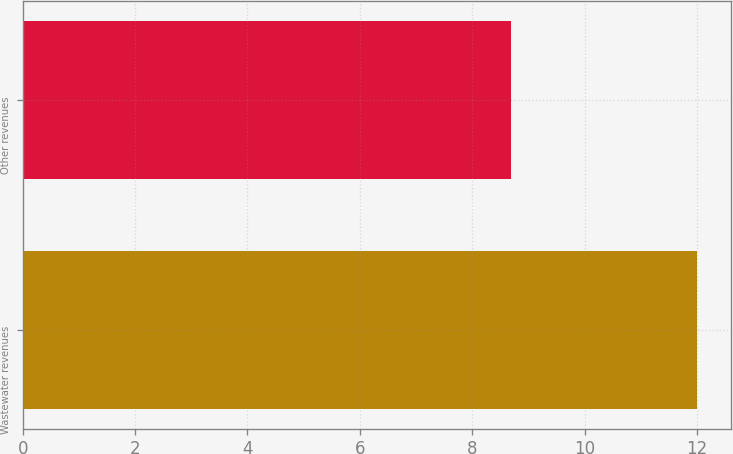Convert chart. <chart><loc_0><loc_0><loc_500><loc_500><bar_chart><fcel>Wastewater revenues<fcel>Other revenues<nl><fcel>12<fcel>8.7<nl></chart> 